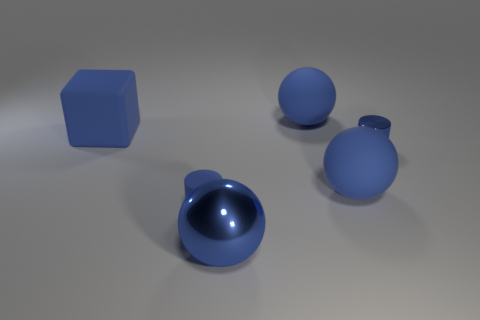Add 1 small metal cylinders. How many objects exist? 7 Subtract all cubes. How many objects are left? 5 Subtract all shiny things. Subtract all big objects. How many objects are left? 0 Add 3 shiny spheres. How many shiny spheres are left? 4 Add 6 large matte balls. How many large matte balls exist? 8 Subtract 0 green cubes. How many objects are left? 6 